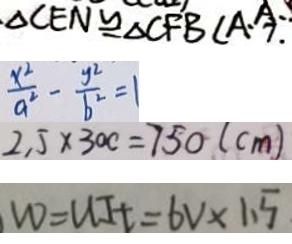Convert formula to latex. <formula><loc_0><loc_0><loc_500><loc_500>\Delta C E N \cong \Delta C F B ( A . 7 
 \frac { x ^ { 2 } } { a ^ { 2 } } - \frac { y ^ { 2 } } { b ^ { 2 } } = 1 
 2 . 5 \times 3 0 c = 7 5 0 ( c m ) 
 W = U I t = 6 V \times 1 . 5</formula> 